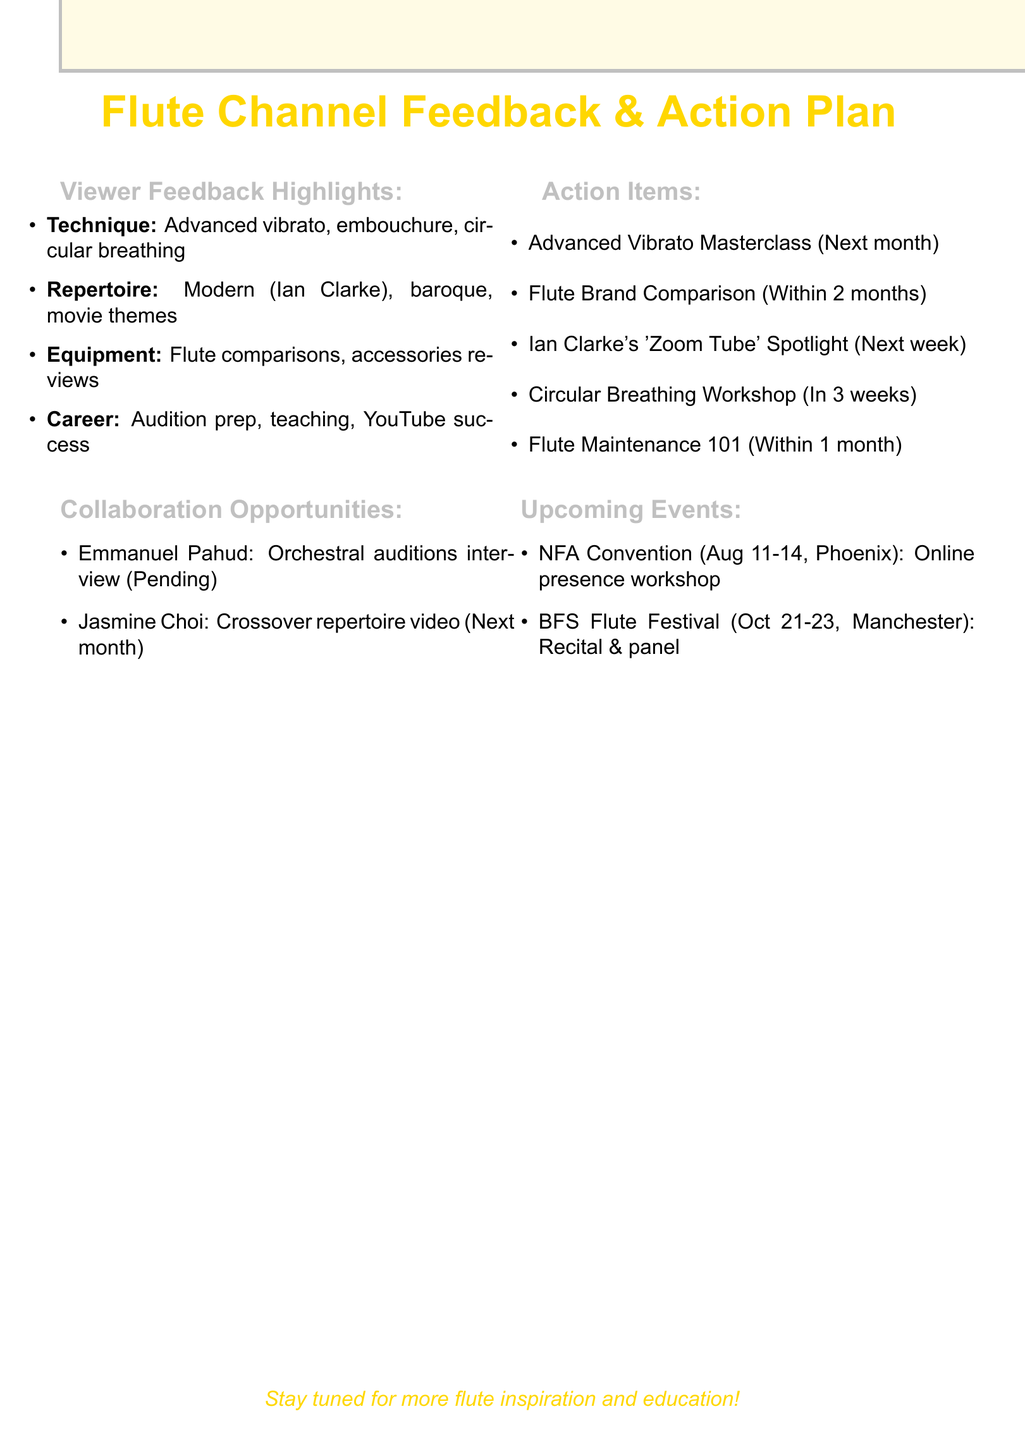what is the title of the document? The title of the document is prominently featured at the top, stating the focus on viewer feedback and action planning for a flute channel.
Answer: Flute Channel Feedback & Action Plan how many categories of viewer feedback are listed? The document lists viewer feedback in four distinct categories: Technique, Repertoire, Equipment, and Career Advice.
Answer: 4 what is the target date for the Advanced Vibrato Masterclass? This action item specifies that the masterclass will be created next month, indicating a clear timeline for content creation.
Answer: Next month who is scheduled for a joint video next month? The document indicates that Jasmine Choi is scheduled for a joint video project on crossover flute repertoire next month.
Answer: Jasmine Choi which flute brand comparison is planned to be filmed? The action item details a plan to film a comprehensive comparison between three specific flute brands: Yamaha, Pearl, and Muramatsu.
Answer: Yamaha, Pearl, Muramatsu what is the date of the National Flute Association Annual Convention? This event is listed with specific dates, indicating when it will take place.
Answer: August 11-14, 2023 what specific workshop will be hosted at the NFA Convention? The document details a workshop focusing on building an online presence for flute musicians, highlighting a particular aspect of musician outreach.
Answer: Building Your Online Flute Presence what type of workshop is being planned for circular breathing? The document outlines a live workshop specifically focused on teaching the basics of circular breathing, which is a technique of interest to viewers.
Answer: Workshop which piece by Ian Clarke will be featured in the upcoming video? The document specifies that there will be a spotlight video on Ian Clarke's piece 'Zoom Tube', indicating a focus on modern repertoire.
Answer: 'Zoom Tube' 